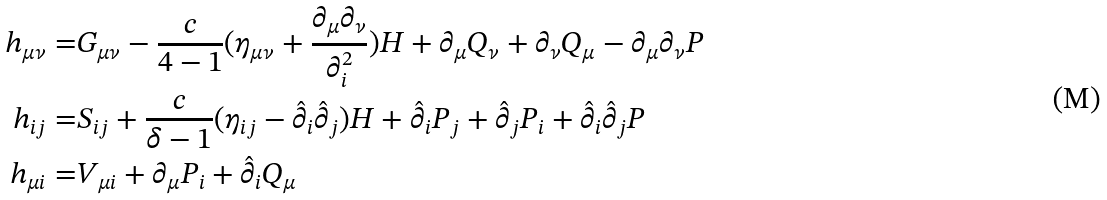Convert formula to latex. <formula><loc_0><loc_0><loc_500><loc_500>h _ { \mu \nu } = & G _ { \mu \nu } - \frac { c } { 4 - 1 } ( \eta _ { \mu \nu } + \frac { \partial _ { \mu } \partial _ { \nu } } { \partial _ { i } ^ { 2 } } ) H + \partial _ { \mu } Q _ { \nu } + \partial _ { \nu } Q _ { \mu } - \partial _ { \mu } \partial _ { \nu } P \\ h _ { i j } = & S _ { i j } + \frac { c } { \delta - 1 } ( \eta _ { i j } - \hat { \partial } _ { i } \hat { \partial } _ { j } ) H + \hat { \partial } _ { i } P _ { j } + \hat { \partial } _ { j } P _ { i } + \hat { \partial } _ { i } \hat { \partial } _ { j } P \\ h _ { \mu i } = & V _ { \mu i } + \partial _ { \mu } P _ { i } + \hat { \partial } _ { i } Q _ { \mu }</formula> 